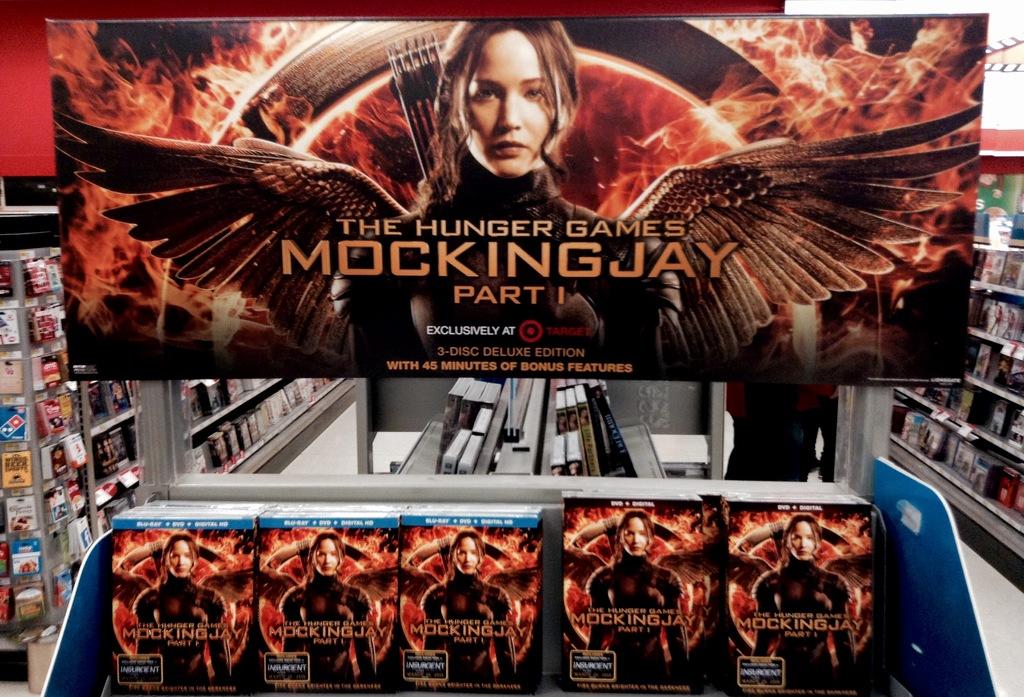What is the name of the movie displayed?
Ensure brevity in your answer.  Mocking jay. What part is it?
Your answer should be very brief. 1. 